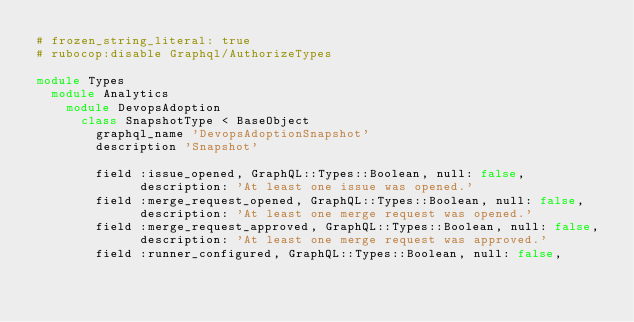Convert code to text. <code><loc_0><loc_0><loc_500><loc_500><_Ruby_># frozen_string_literal: true
# rubocop:disable Graphql/AuthorizeTypes

module Types
  module Analytics
    module DevopsAdoption
      class SnapshotType < BaseObject
        graphql_name 'DevopsAdoptionSnapshot'
        description 'Snapshot'

        field :issue_opened, GraphQL::Types::Boolean, null: false,
              description: 'At least one issue was opened.'
        field :merge_request_opened, GraphQL::Types::Boolean, null: false,
              description: 'At least one merge request was opened.'
        field :merge_request_approved, GraphQL::Types::Boolean, null: false,
              description: 'At least one merge request was approved.'
        field :runner_configured, GraphQL::Types::Boolean, null: false,</code> 